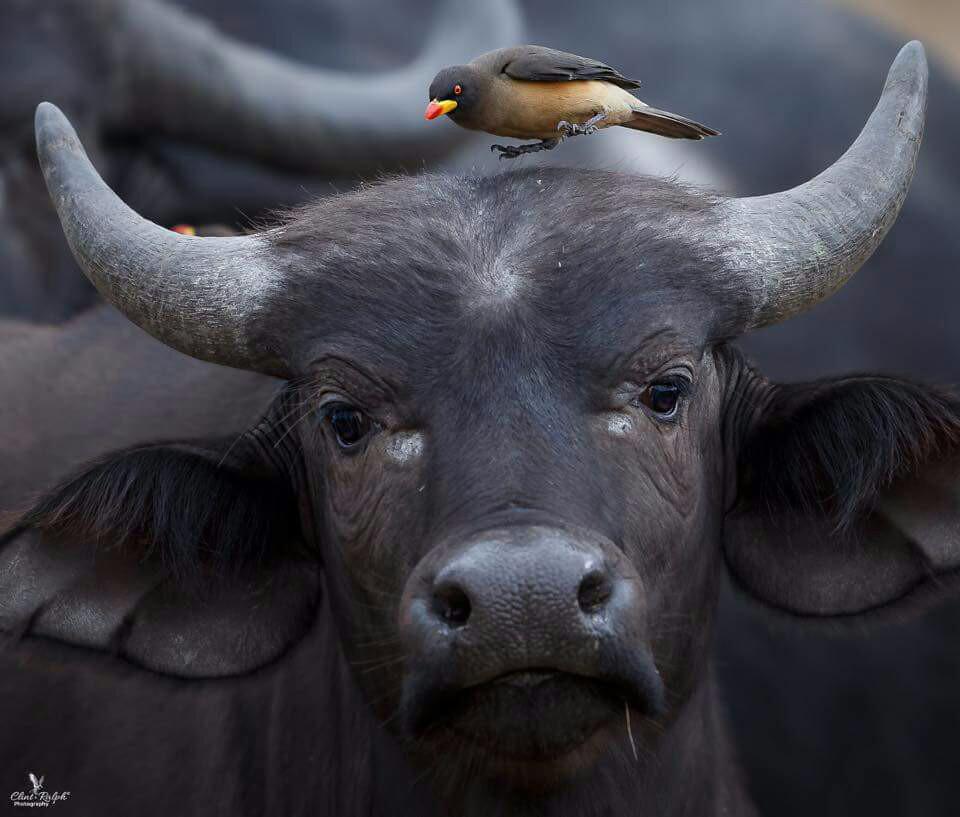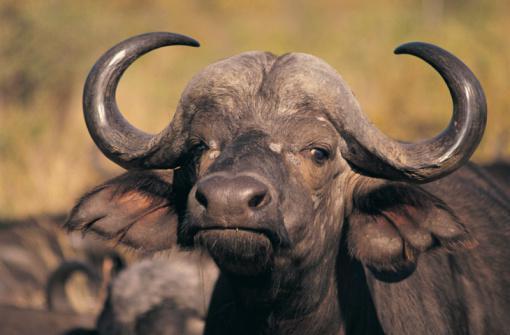The first image is the image on the left, the second image is the image on the right. Analyze the images presented: Is the assertion "At least one bird is landing or on a water buffalo." valid? Answer yes or no. Yes. The first image is the image on the left, the second image is the image on the right. Assess this claim about the two images: "An image features a camera-facing water buffalo with a bird perched on it.". Correct or not? Answer yes or no. Yes. 